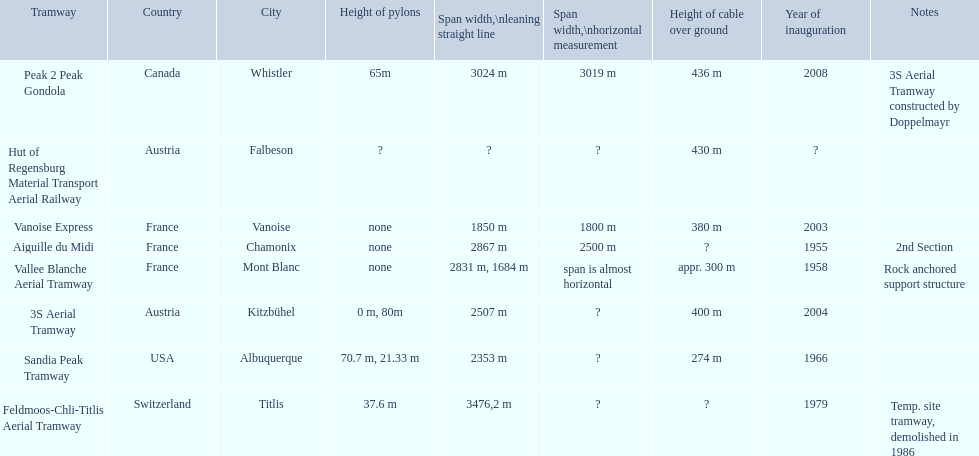What is the inauguration date of the aiguille du midi tramway? 1955. When did the 3s aerial tramway have its inauguration? 2004. Which among them had an earlier inauguration? Aiguille du Midi. 